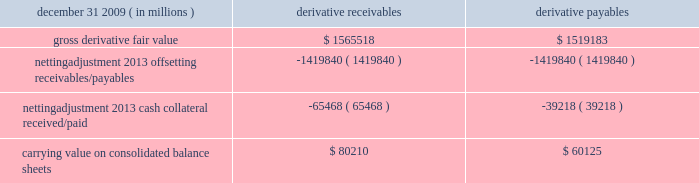Jpmorgan chase & co./2009 annual report 181 the table shows the current credit risk of derivative receivables after netting adjustments , and the current liquidity risk of derivative payables after netting adjustments , as of december 31 , 2009. .
In addition to the collateral amounts reflected in the table above , at december 31 , 2009 , the firm had received and posted liquid secu- rities collateral in the amount of $ 15.5 billion and $ 11.7 billion , respectively .
The firm also receives and delivers collateral at the initiation of derivative transactions , which is available as security against potential exposure that could arise should the fair value of the transactions move in the firm 2019s or client 2019s favor , respectively .
Furthermore , the firm and its counterparties hold collateral related to contracts that have a non-daily call frequency for collateral to be posted , and collateral that the firm or a counterparty has agreed to return but has not yet settled as of the reporting date .
At december 31 , 2009 , the firm had received $ 16.9 billion and delivered $ 5.8 billion of such additional collateral .
These amounts were not netted against the derivative receivables and payables in the table above , because , at an individual counterparty level , the collateral exceeded the fair value exposure at december 31 , 2009 .
Credit derivatives credit derivatives are financial instruments whose value is derived from the credit risk associated with the debt of a third-party issuer ( the reference entity ) and which allow one party ( the protection purchaser ) to transfer that risk to another party ( the protection seller ) .
Credit derivatives expose the protection purchaser to the creditworthiness of the protection seller , as the protection seller is required to make payments under the contract when the reference entity experiences a credit event , such as a bankruptcy , a failure to pay its obligation or a restructuring .
The seller of credit protection receives a premium for providing protection but has the risk that the underlying instrument referenced in the contract will be subject to a credit event .
The firm is both a purchaser and seller of protection in the credit derivatives market and uses these derivatives for two primary purposes .
First , in its capacity as a market-maker in the dealer/client business , the firm actively risk manages a portfolio of credit derivatives by purchasing and selling credit protection , pre- dominantly on corporate debt obligations , to meet the needs of customers .
As a seller of protection , the firm 2019s exposure to a given reference entity may be offset partially , or entirely , with a contract to purchase protection from another counterparty on the same or similar reference entity .
Second , the firm uses credit derivatives to mitigate credit risk associated with its overall derivative receivables and traditional commercial credit lending exposures ( loans and unfunded commitments ) as well as to manage its exposure to residential and commercial mortgages .
See note 3 on pages 156--- 173 of this annual report for further information on the firm 2019s mortgage-related exposures .
In accomplishing the above , the firm uses different types of credit derivatives .
Following is a summary of various types of credit derivatives .
Credit default swaps credit derivatives may reference the credit of either a single refer- ence entity ( 201csingle-name 201d ) or a broad-based index , as described further below .
The firm purchases and sells protection on both single- name and index-reference obligations .
Single-name cds and index cds contracts are both otc derivative contracts .
Single- name cds are used to manage the default risk of a single reference entity , while cds index are used to manage credit risk associated with the broader credit markets or credit market segments .
Like the s&p 500 and other market indices , a cds index is comprised of a portfolio of cds across many reference entities .
New series of cds indices are established approximately every six months with a new underlying portfolio of reference entities to reflect changes in the credit markets .
If one of the reference entities in the index experi- ences a credit event , then the reference entity that defaulted is removed from the index .
Cds can also be referenced against spe- cific portfolios of reference names or against customized exposure levels based on specific client demands : for example , to provide protection against the first $ 1 million of realized credit losses in a $ 10 million portfolio of exposure .
Such structures are commonly known as tranche cds .
For both single-name cds contracts and index cds , upon the occurrence of a credit event , under the terms of a cds contract neither party to the cds contract has recourse to the reference entity .
The protection purchaser has recourse to the protection seller for the difference between the face value of the cds contract and the fair value of the reference obligation at the time of settling the credit derivative contract , also known as the recovery value .
The protection purchaser does not need to hold the debt instrument of the underlying reference entity in order to receive amounts due under the cds contract when a credit event occurs .
Credit-linked notes a credit linked note ( 201ccln 201d ) is a funded credit derivative where the issuer of the cln purchases credit protection on a referenced entity from the note investor .
Under the contract , the investor pays the issuer par value of the note at the inception of the transaction , and in return , the issuer pays periodic payments to the investor , based on the credit risk of the referenced entity .
The issuer also repays the investor the par value of the note at maturity unless the reference entity experiences a specified credit event .
In that event , the issuer is not obligated to repay the par value of the note , but rather , the issuer pays the investor the difference between the par value of the note .
Considering the year 2009 , what is the difference between the carrying value on consolidated balance sheets for derivative receivables and derivative payables , in millions? 
Rationale: its the variation between each carrying value on consolidated balance sheets .
Computations: (80210 - 60125)
Answer: 20085.0. 